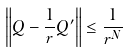<formula> <loc_0><loc_0><loc_500><loc_500>\left \| Q - \frac { 1 } { r } Q ^ { \prime } \right \| \leq \frac { 1 } { r ^ { N } }</formula> 